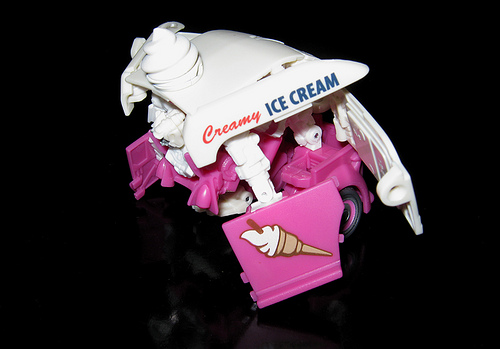<image>
Is the ice cream behind the truck? No. The ice cream is not behind the truck. From this viewpoint, the ice cream appears to be positioned elsewhere in the scene. 